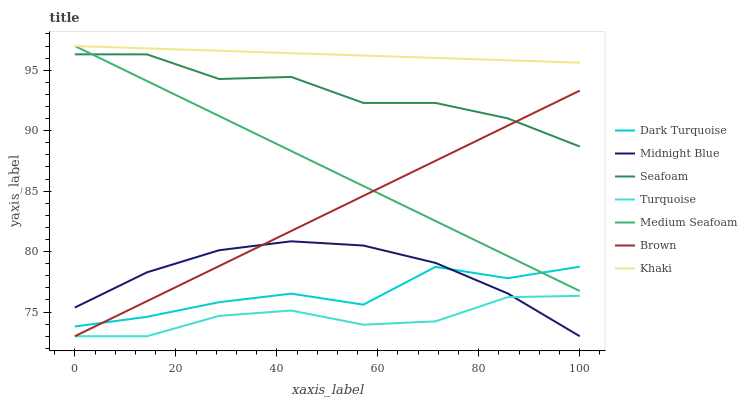Does Turquoise have the minimum area under the curve?
Answer yes or no. Yes. Does Khaki have the maximum area under the curve?
Answer yes or no. Yes. Does Khaki have the minimum area under the curve?
Answer yes or no. No. Does Turquoise have the maximum area under the curve?
Answer yes or no. No. Is Khaki the smoothest?
Answer yes or no. Yes. Is Dark Turquoise the roughest?
Answer yes or no. Yes. Is Turquoise the smoothest?
Answer yes or no. No. Is Turquoise the roughest?
Answer yes or no. No. Does Brown have the lowest value?
Answer yes or no. Yes. Does Khaki have the lowest value?
Answer yes or no. No. Does Medium Seafoam have the highest value?
Answer yes or no. Yes. Does Turquoise have the highest value?
Answer yes or no. No. Is Dark Turquoise less than Seafoam?
Answer yes or no. Yes. Is Khaki greater than Brown?
Answer yes or no. Yes. Does Medium Seafoam intersect Khaki?
Answer yes or no. Yes. Is Medium Seafoam less than Khaki?
Answer yes or no. No. Is Medium Seafoam greater than Khaki?
Answer yes or no. No. Does Dark Turquoise intersect Seafoam?
Answer yes or no. No. 